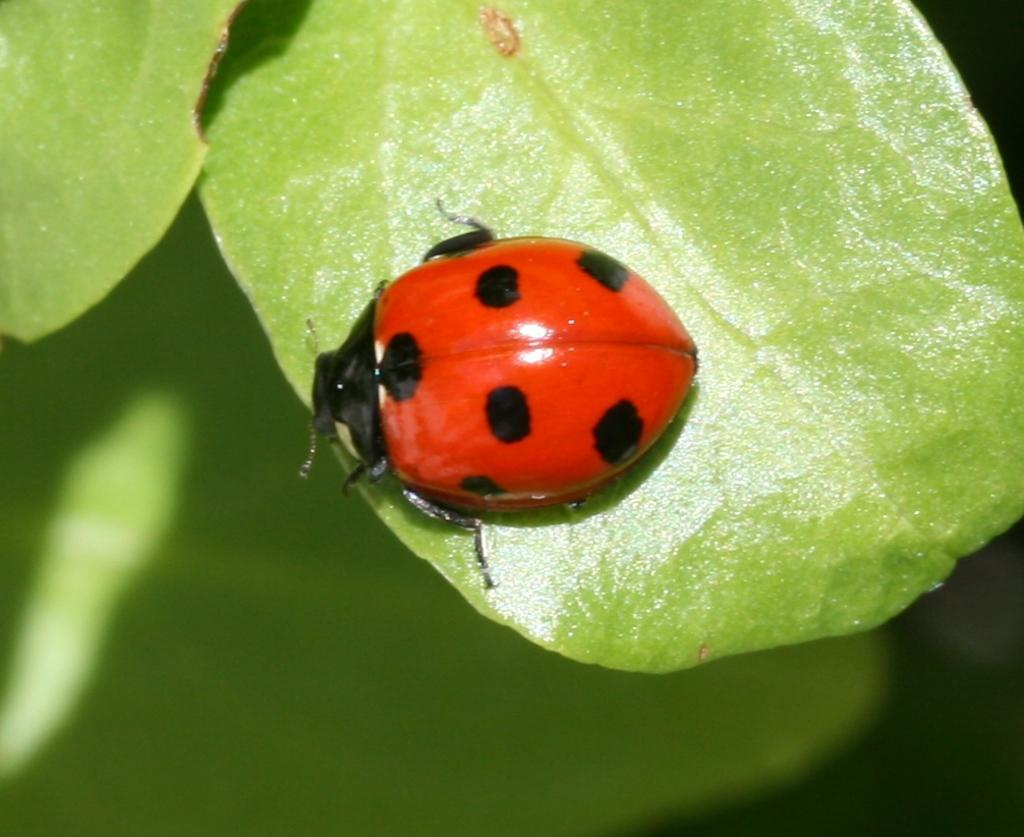What type of creature can be seen in the image? There is an insect in the image. What type of vegetation is present in the image? There are leaves in the image. Can you describe the background of the image? The background of the image is blurry. What historical invention is depicted in the image? There is no historical invention depicted in the image; it features an insect and leaves. What type of truck can be seen in the image? There is no truck present in the image. 